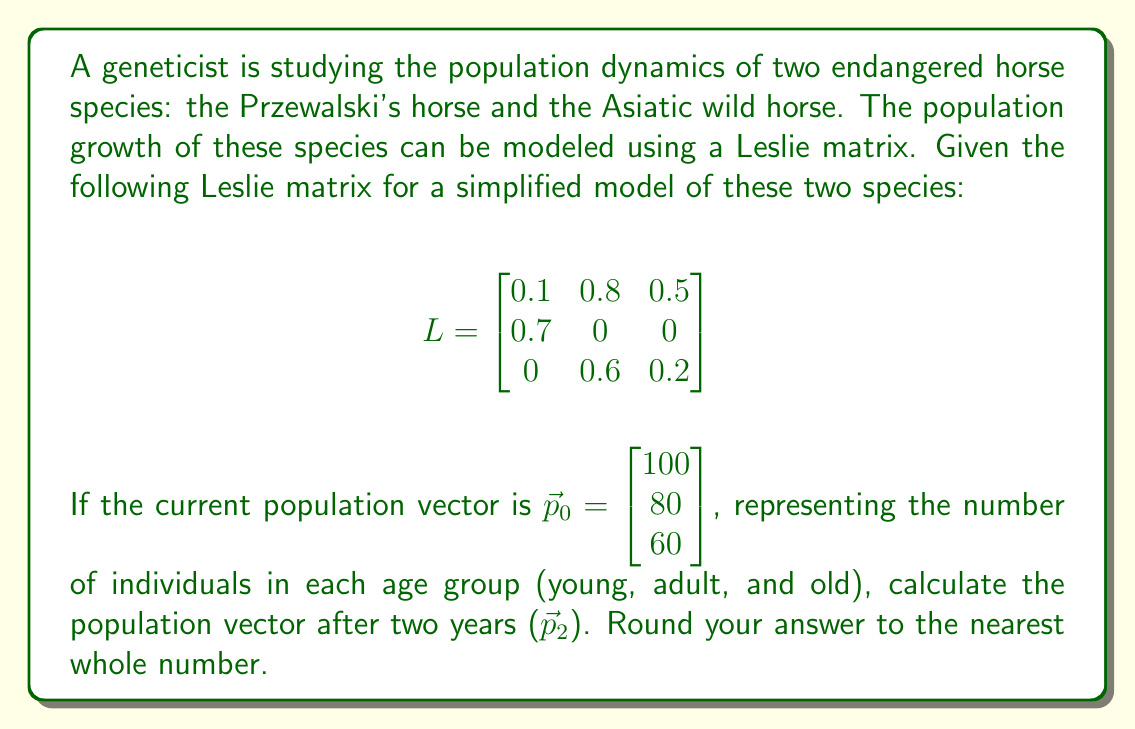Could you help me with this problem? To solve this problem, we need to use matrix multiplication to apply the Leslie matrix to the population vector twice, as we want to calculate the population after two years.

Step 1: Calculate the population after one year ($\vec{p}_1$)
$$\vec{p}_1 = L \cdot \vec{p}_0$$

$$\vec{p}_1 = \begin{bmatrix}
0.1 & 0.8 & 0.5 \\
0.7 & 0 & 0 \\
0 & 0.6 & 0.2
\end{bmatrix} \cdot \begin{bmatrix}
100 \\
80 \\
60
\end{bmatrix}$$

$$\vec{p}_1 = \begin{bmatrix}
(0.1 \cdot 100) + (0.8 \cdot 80) + (0.5 \cdot 60) \\
(0.7 \cdot 100) + (0 \cdot 80) + (0 \cdot 60) \\
(0 \cdot 100) + (0.6 \cdot 80) + (0.2 \cdot 60)
\end{bmatrix}$$

$$\vec{p}_1 = \begin{bmatrix}
10 + 64 + 30 \\
70 + 0 + 0 \\
0 + 48 + 12
\end{bmatrix} = \begin{bmatrix}
104 \\
70 \\
60
\end{bmatrix}$$

Step 2: Calculate the population after two years ($\vec{p}_2$)
$$\vec{p}_2 = L \cdot \vec{p}_1$$

$$\vec{p}_2 = \begin{bmatrix}
0.1 & 0.8 & 0.5 \\
0.7 & 0 & 0 \\
0 & 0.6 & 0.2
\end{bmatrix} \cdot \begin{bmatrix}
104 \\
70 \\
60
\end{bmatrix}$$

$$\vec{p}_2 = \begin{bmatrix}
(0.1 \cdot 104) + (0.8 \cdot 70) + (0.5 \cdot 60) \\
(0.7 \cdot 104) + (0 \cdot 70) + (0 \cdot 60) \\
(0 \cdot 104) + (0.6 \cdot 70) + (0.2 \cdot 60)
\end{bmatrix}$$

$$\vec{p}_2 = \begin{bmatrix}
10.4 + 56 + 30 \\
72.8 + 0 + 0 \\
0 + 42 + 12
\end{bmatrix} = \begin{bmatrix}
96.4 \\
72.8 \\
54
\end{bmatrix}$$

Rounding to the nearest whole number:

$$\vec{p}_2 \approx \begin{bmatrix}
96 \\
73 \\
54
\end{bmatrix}$$
Answer: $$\vec{p}_2 \approx \begin{bmatrix}
96 \\
73 \\
54
\end{bmatrix}$$ 